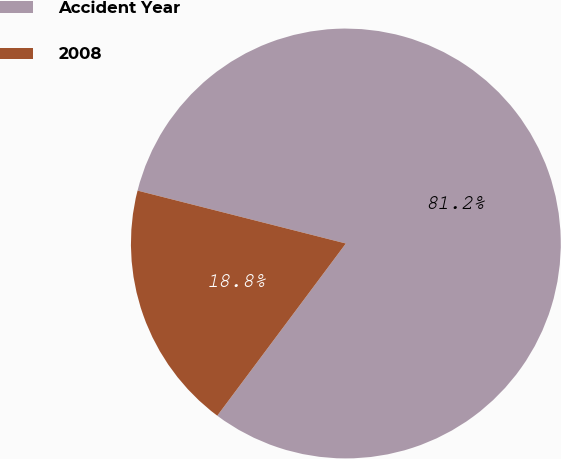<chart> <loc_0><loc_0><loc_500><loc_500><pie_chart><fcel>Accident Year<fcel>2008<nl><fcel>81.25%<fcel>18.75%<nl></chart> 